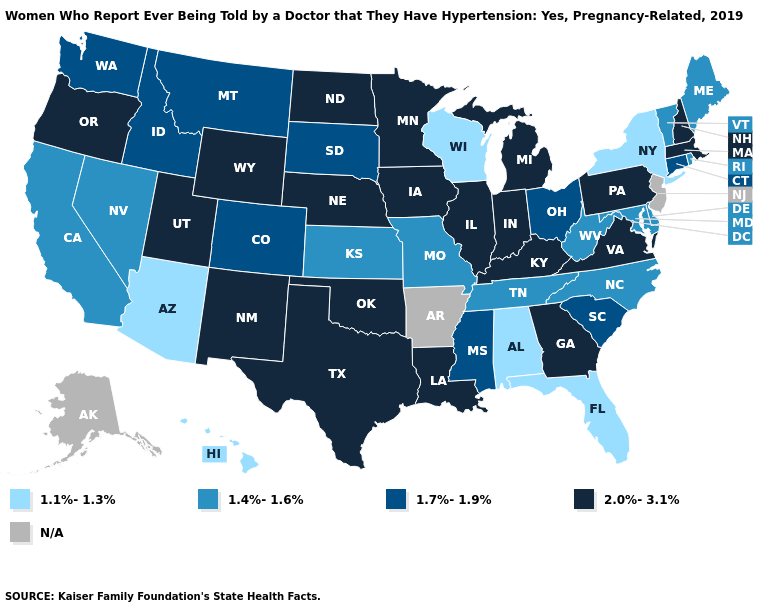What is the lowest value in the South?
Concise answer only. 1.1%-1.3%. Name the states that have a value in the range 1.7%-1.9%?
Concise answer only. Colorado, Connecticut, Idaho, Mississippi, Montana, Ohio, South Carolina, South Dakota, Washington. How many symbols are there in the legend?
Quick response, please. 5. Name the states that have a value in the range 2.0%-3.1%?
Keep it brief. Georgia, Illinois, Indiana, Iowa, Kentucky, Louisiana, Massachusetts, Michigan, Minnesota, Nebraska, New Hampshire, New Mexico, North Dakota, Oklahoma, Oregon, Pennsylvania, Texas, Utah, Virginia, Wyoming. What is the value of Vermont?
Write a very short answer. 1.4%-1.6%. What is the value of New Hampshire?
Give a very brief answer. 2.0%-3.1%. What is the lowest value in the USA?
Write a very short answer. 1.1%-1.3%. What is the value of California?
Be succinct. 1.4%-1.6%. What is the lowest value in the USA?
Be succinct. 1.1%-1.3%. Name the states that have a value in the range 1.7%-1.9%?
Give a very brief answer. Colorado, Connecticut, Idaho, Mississippi, Montana, Ohio, South Carolina, South Dakota, Washington. Name the states that have a value in the range 1.1%-1.3%?
Short answer required. Alabama, Arizona, Florida, Hawaii, New York, Wisconsin. Name the states that have a value in the range N/A?
Concise answer only. Alaska, Arkansas, New Jersey. Which states have the lowest value in the USA?
Give a very brief answer. Alabama, Arizona, Florida, Hawaii, New York, Wisconsin. Among the states that border Colorado , does Kansas have the highest value?
Be succinct. No. 